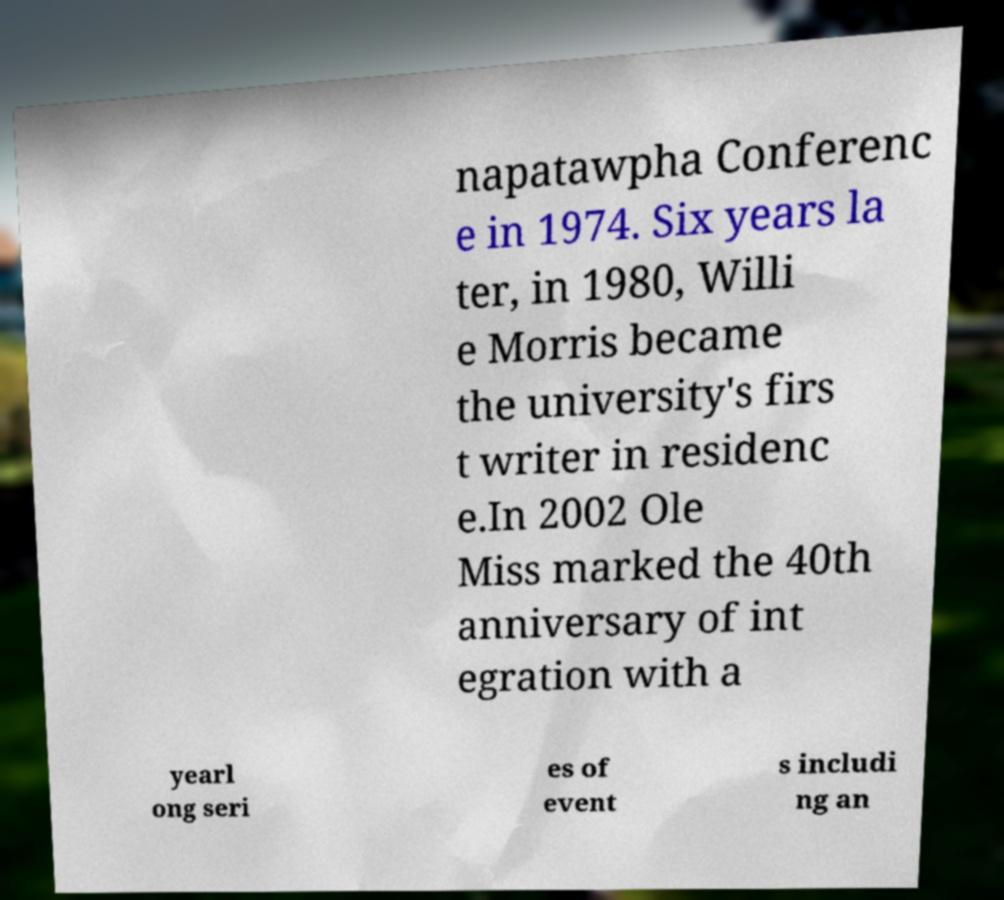Please identify and transcribe the text found in this image. napatawpha Conferenc e in 1974. Six years la ter, in 1980, Willi e Morris became the university's firs t writer in residenc e.In 2002 Ole Miss marked the 40th anniversary of int egration with a yearl ong seri es of event s includi ng an 